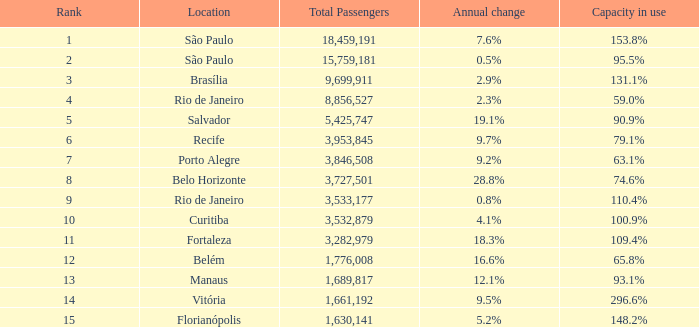Which area has a yearly alteration of São Paulo. Could you parse the entire table? {'header': ['Rank', 'Location', 'Total Passengers', 'Annual change', 'Capacity in use'], 'rows': [['1', 'São Paulo', '18,459,191', '7.6%', '153.8%'], ['2', 'São Paulo', '15,759,181', '0.5%', '95.5%'], ['3', 'Brasília', '9,699,911', '2.9%', '131.1%'], ['4', 'Rio de Janeiro', '8,856,527', '2.3%', '59.0%'], ['5', 'Salvador', '5,425,747', '19.1%', '90.9%'], ['6', 'Recife', '3,953,845', '9.7%', '79.1%'], ['7', 'Porto Alegre', '3,846,508', '9.2%', '63.1%'], ['8', 'Belo Horizonte', '3,727,501', '28.8%', '74.6%'], ['9', 'Rio de Janeiro', '3,533,177', '0.8%', '110.4%'], ['10', 'Curitiba', '3,532,879', '4.1%', '100.9%'], ['11', 'Fortaleza', '3,282,979', '18.3%', '109.4%'], ['12', 'Belém', '1,776,008', '16.6%', '65.8%'], ['13', 'Manaus', '1,689,817', '12.1%', '93.1%'], ['14', 'Vitória', '1,661,192', '9.5%', '296.6%'], ['15', 'Florianópolis', '1,630,141', '5.2%', '148.2%']]} 